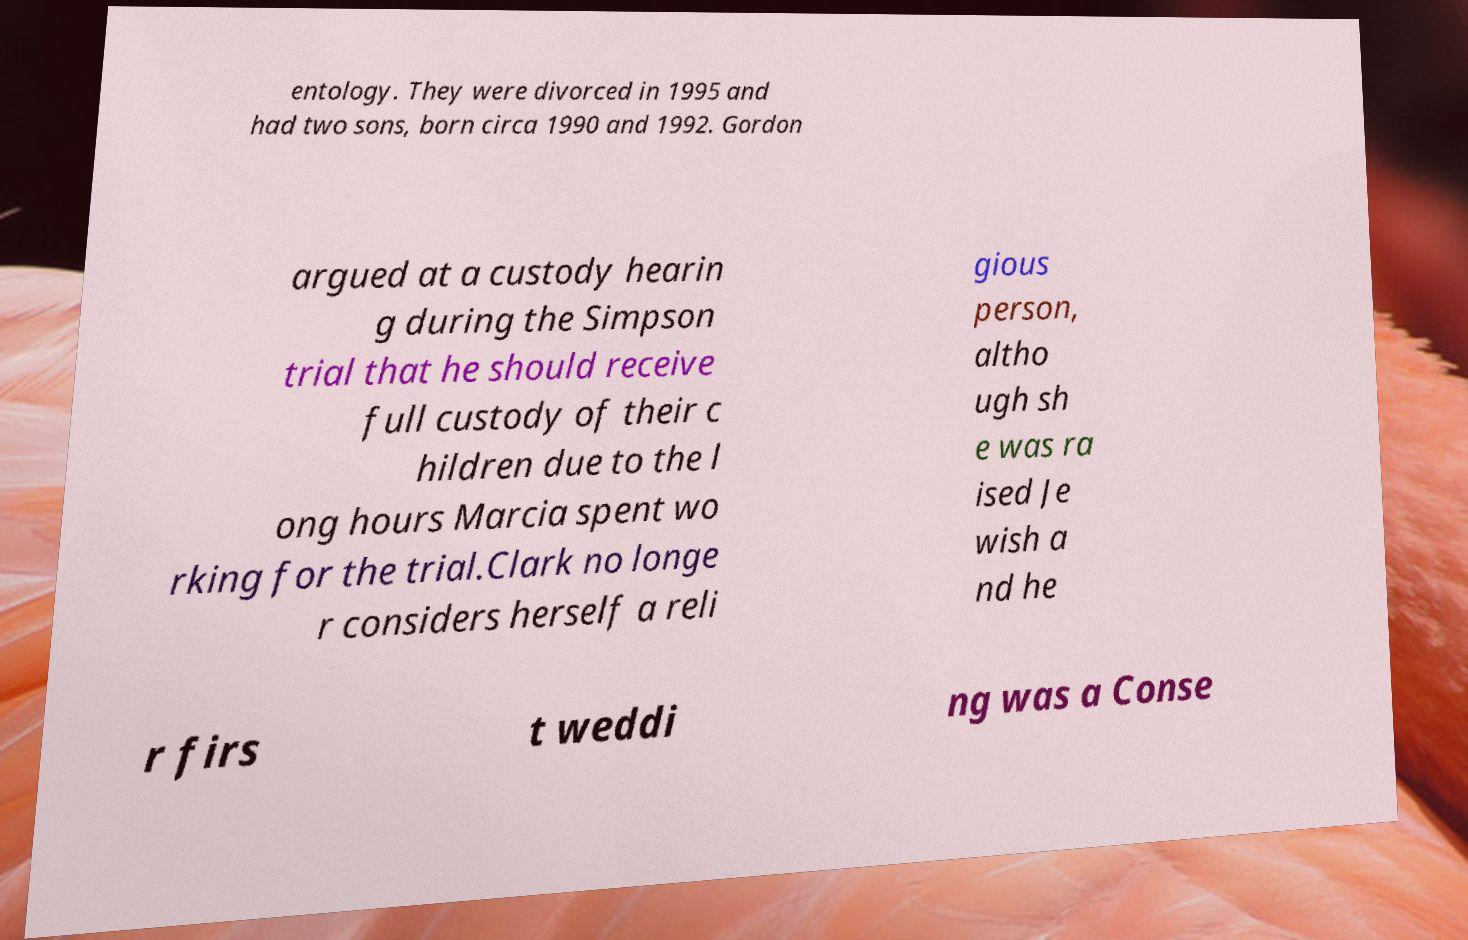Can you accurately transcribe the text from the provided image for me? entology. They were divorced in 1995 and had two sons, born circa 1990 and 1992. Gordon argued at a custody hearin g during the Simpson trial that he should receive full custody of their c hildren due to the l ong hours Marcia spent wo rking for the trial.Clark no longe r considers herself a reli gious person, altho ugh sh e was ra ised Je wish a nd he r firs t weddi ng was a Conse 